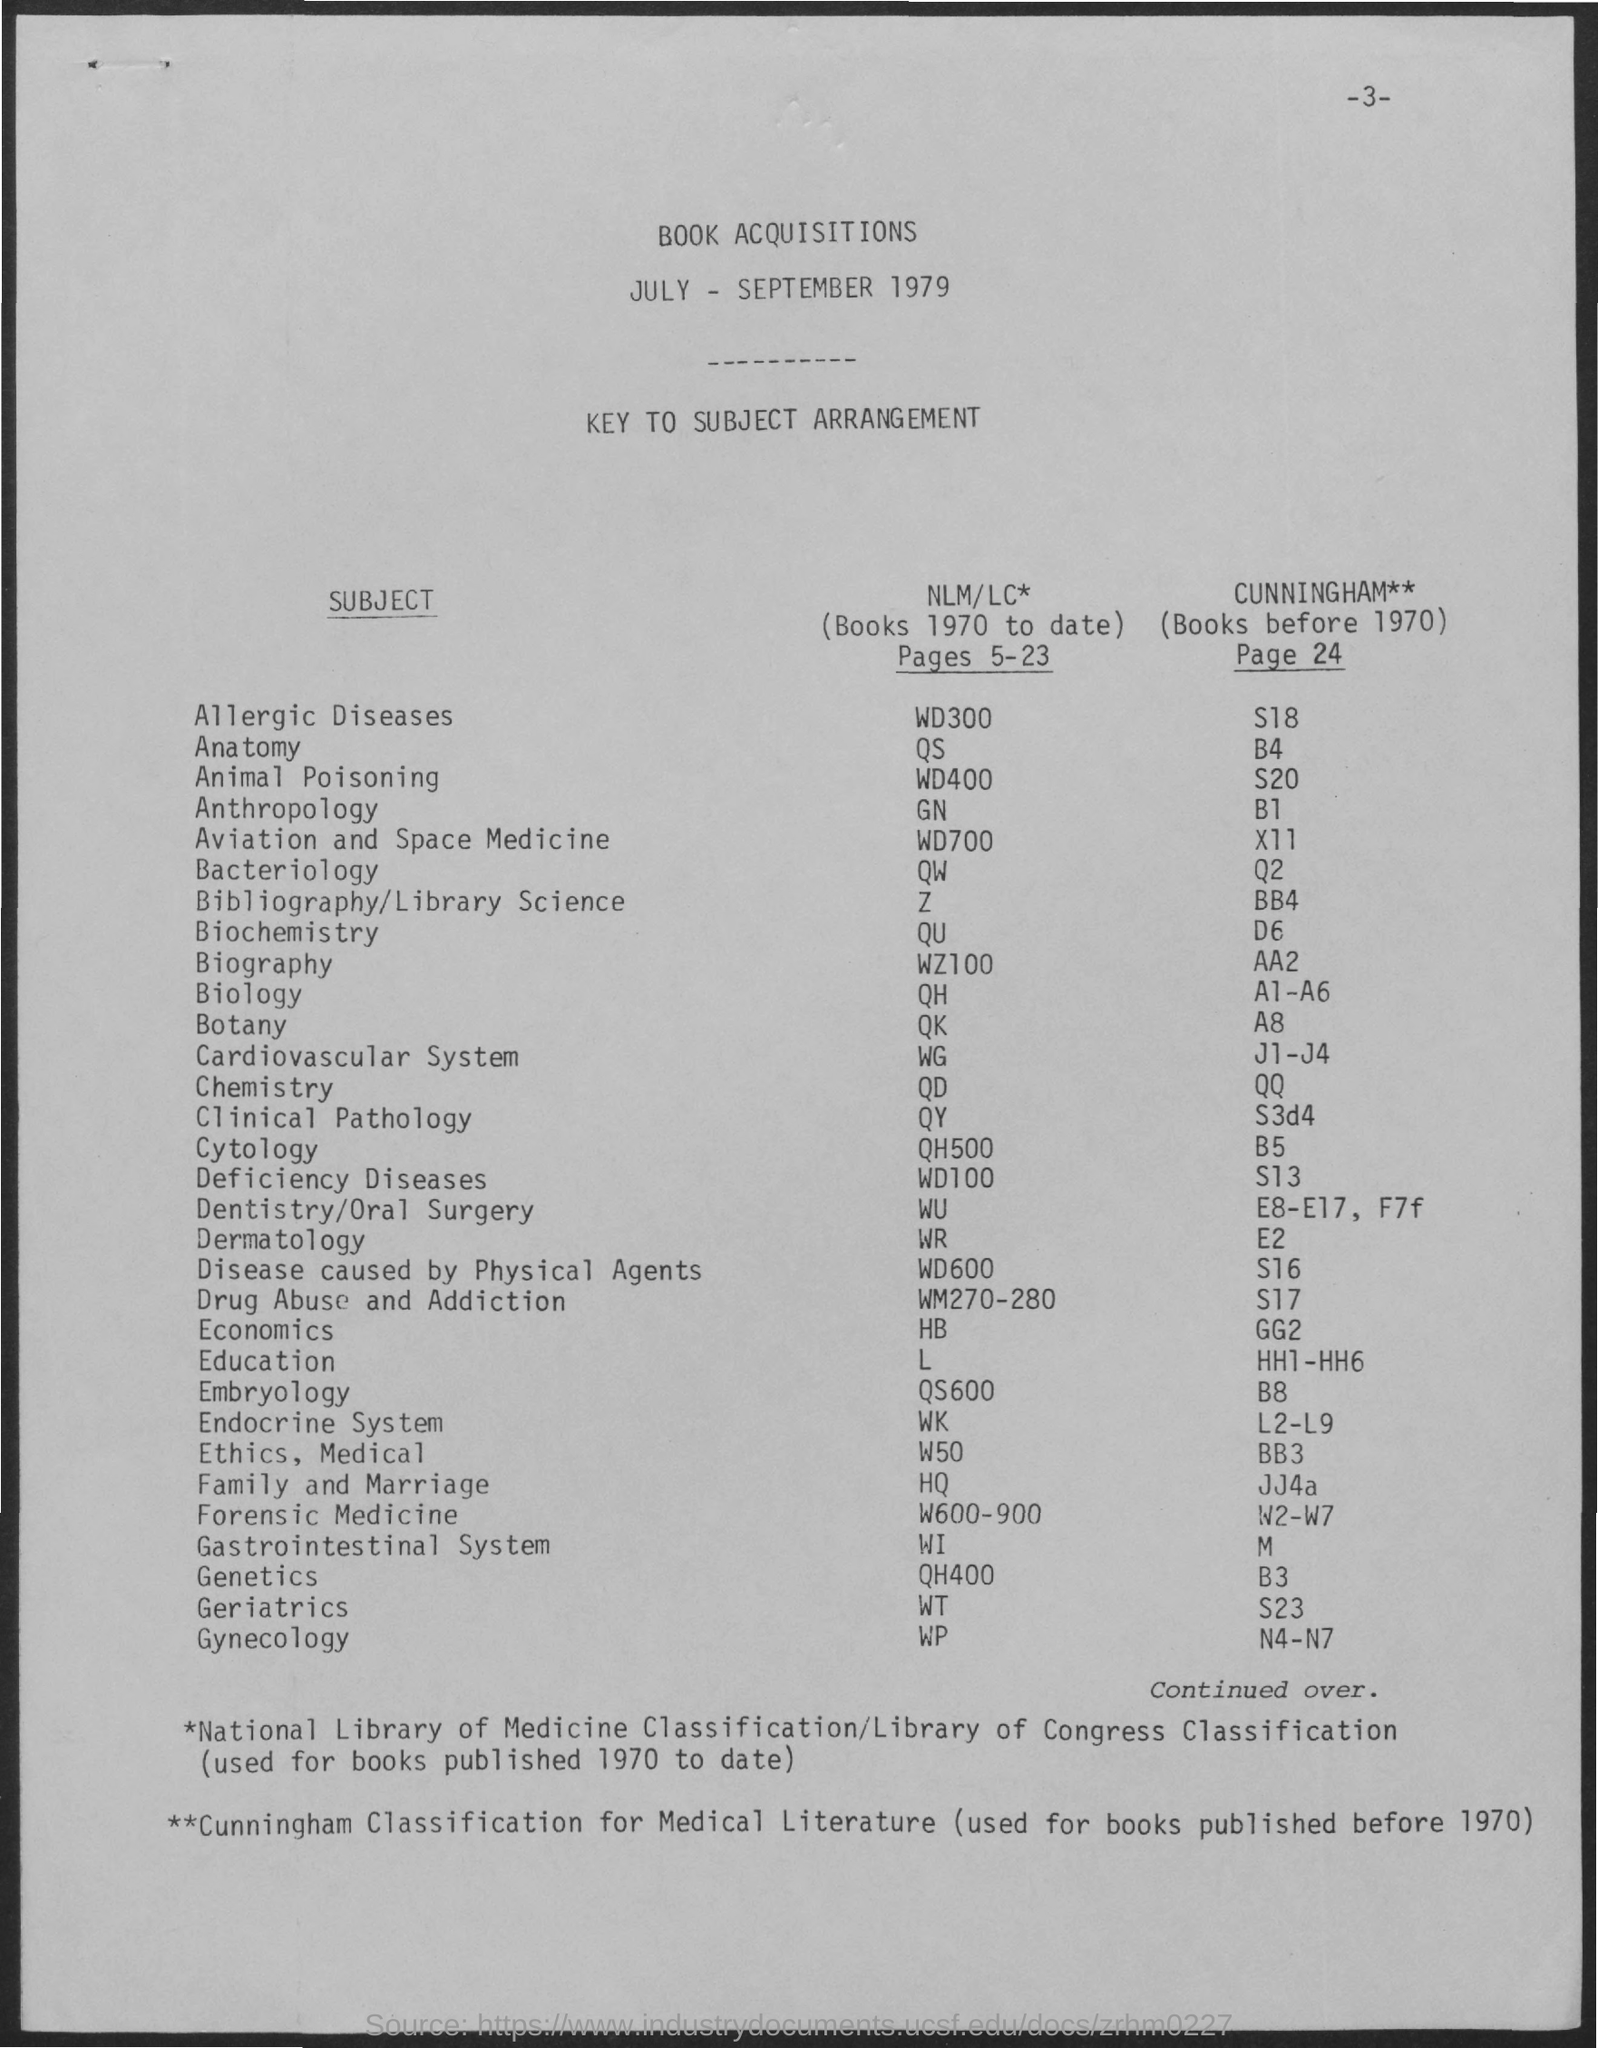Highlight a few significant elements in this photo. The page number is 3 and counting. The title of the document is 'Book Acquisitions'. The Cunningham Classification is used for books that were published before 1970. The National Library of Medicine Classification and the Library of Congress Classification are used to classify books published from 1970 to date. 